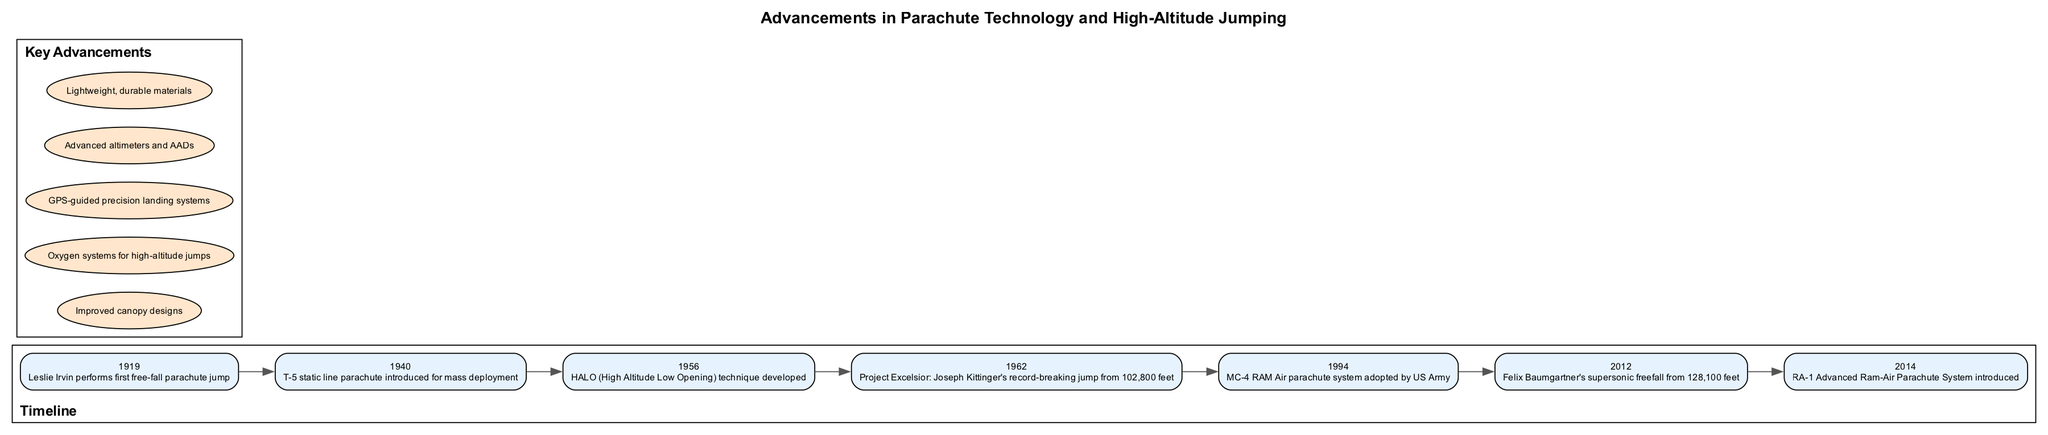What year did Leslie Irvin perform the first free-fall parachute jump? The timeline indicates that the event of Leslie Irvin's first free-fall parachute jump occurred in 1919.
Answer: 1919 What advancement was introduced in 1940? According to the timeline, the T-5 static line parachute was introduced for mass deployment in 1940.
Answer: T-5 static line parachute How many key advancements are listed in the diagram? By counting the entries in the key advancements section, there are five key advancements listed in total.
Answer: 5 Which significant jump height was achieved by Joseph Kittinger? The diagram specifies that Joseph Kittinger's record-breaking jump in Project Excelsior was from a height of 102,800 feet in 1962.
Answer: 102,800 feet What event occurred in 2012? The timeline indicates that in 2012, Felix Baumgartner made a supersonic freefall from 128,100 feet.
Answer: Felix Baumgartner's supersonic freefall What was the last advancement listed in the key advancements section? The last entry in the key advancements section is the Advanced Ram-Air Parachute System, introduced in 2014.
Answer: RA-1 Advanced Ram-Air Parachute System Which technique was developed in 1956? The timeline states that the HALO (High Altitude Low Opening) technique was developed in 1956.
Answer: HALO technique What is the significance of the year 1994 in the timeline? The year 1994 is significant because it marks the adoption of the MC-4 RAM Air parachute system by the US Army.
Answer: MC-4 RAM Air parachute system What are GPS-guided precision landing systems considered in the diagram? In the diagram, GPS-guided precision landing systems are categorized as one of the key advancements in parachute technology.
Answer: Key advancement 